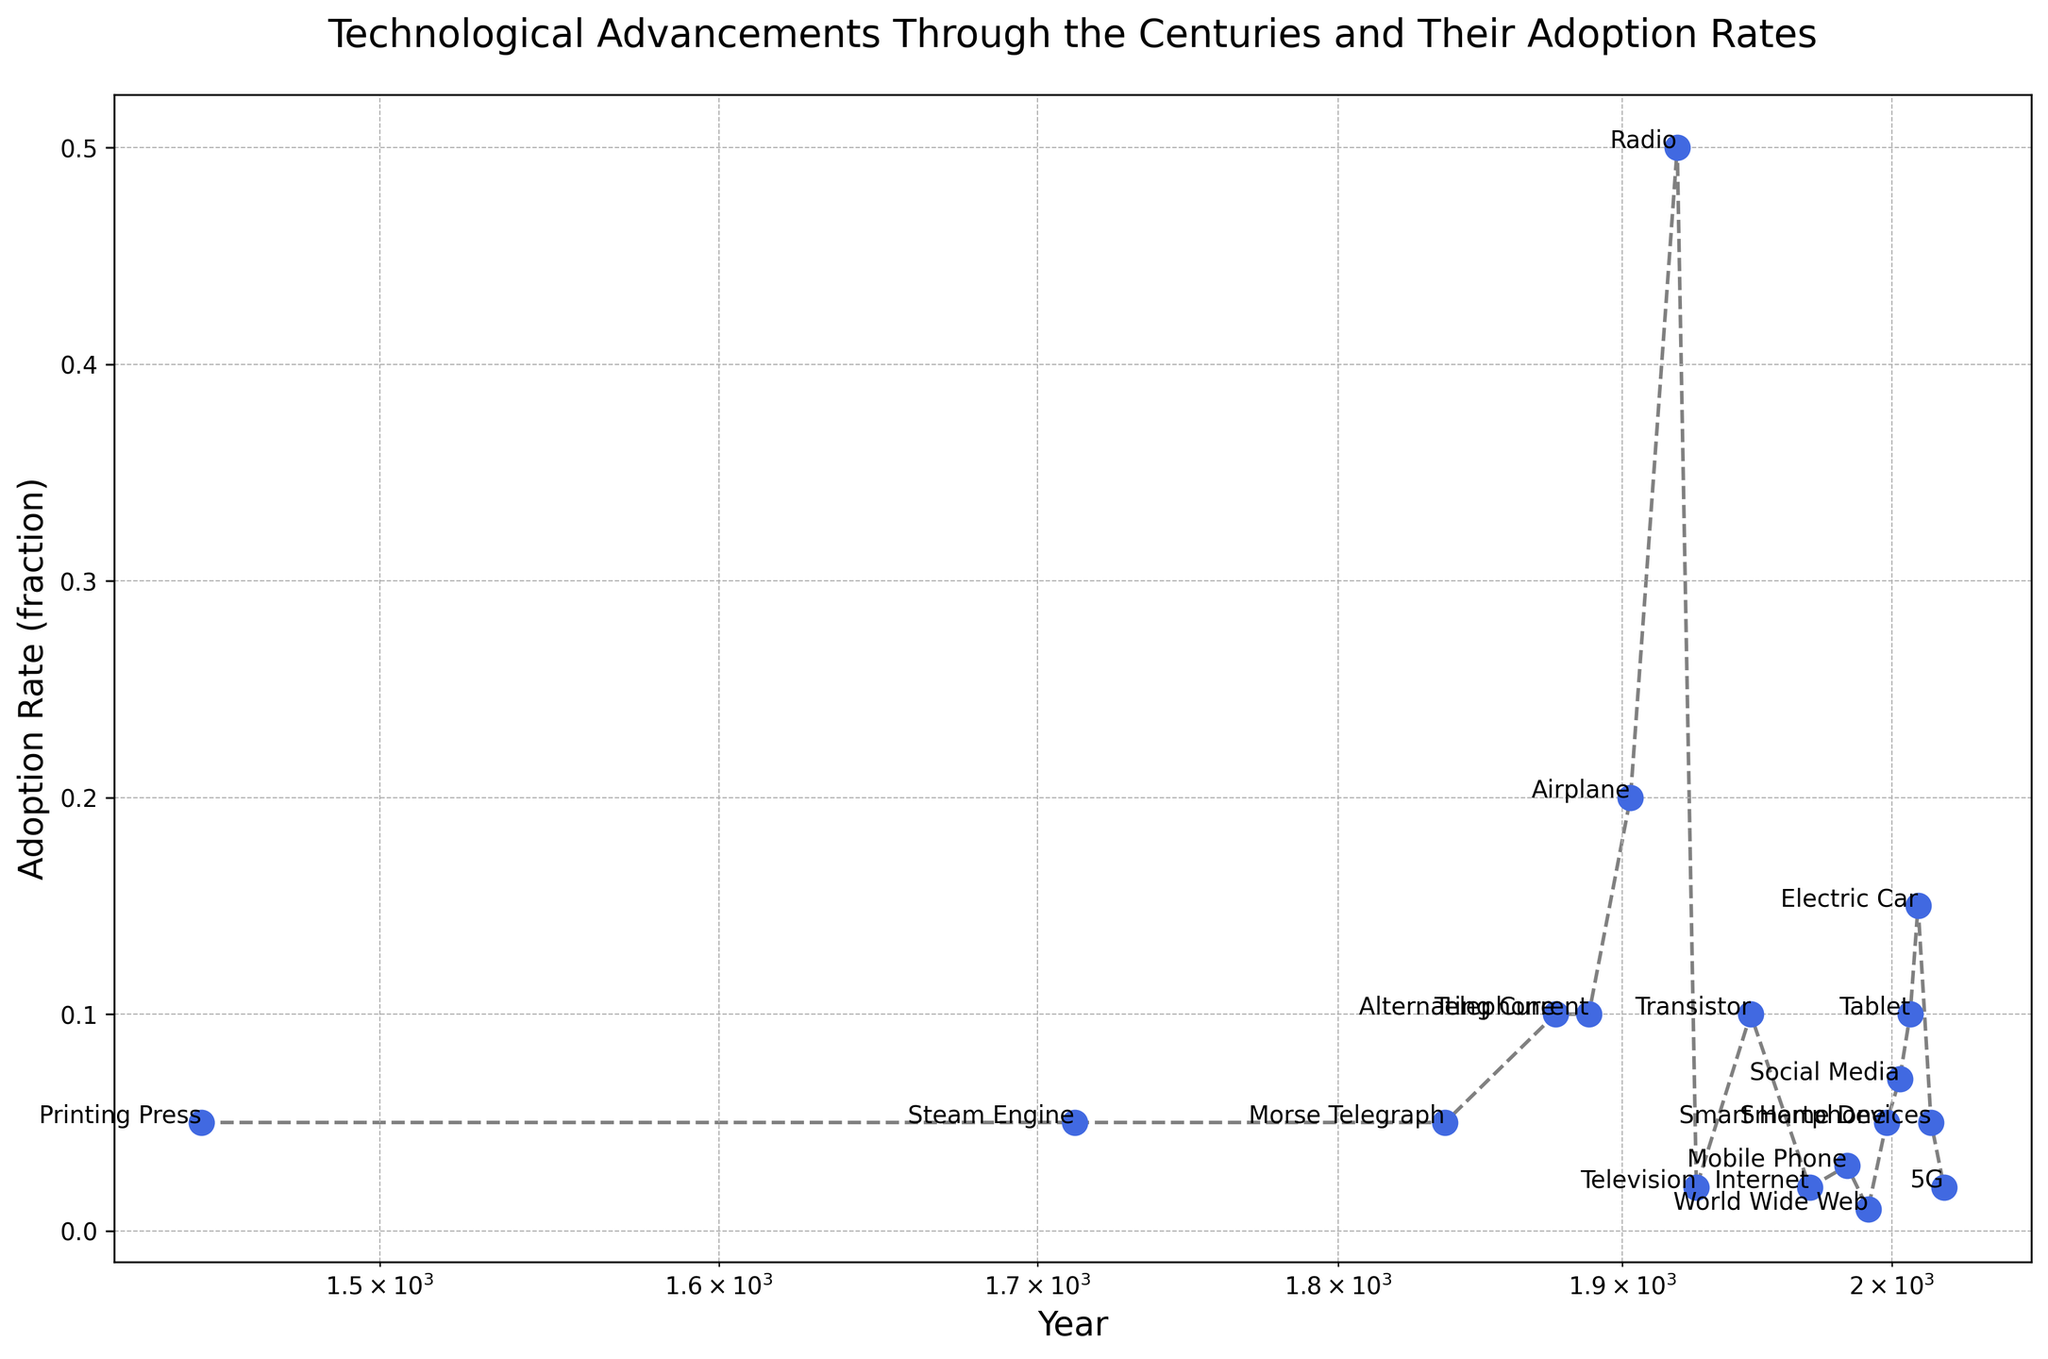What's the earliest year technology shown on the plot? Observe the x-axis and identify the lowest value representing the year of the earliest technology shown.
Answer: 1450 Which technology has the highest adoption rate in the data? From the plot, the technology with the highest adoption rate will be at the highest point on the y-axis.
Answer: Radio What is the adoption rate difference between the Internet and the World Wide Web? Locate the points for the Internet and World Wide Web and subtract the adoption rate of the World Wide Web (0.01) from that of the Internet (0.02).
Answer: 0.01 How many technologies have an adoption rate of 0.1 or more? Count the number of points that are positioned at 0.1 or higher on the y-axis.
Answer: 5 Which technology was adopted faster: the Mobile Phone or the Smartphone? Compare the y-axis positions for the Mobile Phone (0.03) and Smartphone (0.05) and identify which is higher.
Answer: Smartphone In which century were the most listed technologies introduced? Count the number of technologies per century by grouping the x-axis values (year) and then identify the century with the highest count.
Answer: 20th Century What is the median adoption rate of all technologies listed? List all adoption rates, sort them, and find the middle value. The rates are: 0.05, 0.05, 0.05, 0.1, 0.1, 0.2, 0.5, 0.02, 0.1, 0.02, 0.03, 0.01, 0.05, 0.07, 0.1, 0.15, 0.05, 0.02. The middle values are 0.05 and 0.05, so the median is (0.05 + 0.05) / 2 = 0.05.
Answer: 0.05 Which technology's adoption rate is closest to 0.15? Find the point on the plot closest to 0.15 on the y-axis.
Answer: Electric Car Is there a technology with an adoption rate increase of 0.07 or more from its first listed instance to a subsequent technology? Find technologies listed in succession and compare their adoption rates to see if any increment by at least 0.07. The Radio (0.5) and previous technologies show an increase greater than 0.07 from their rates.
Answer: Yes 